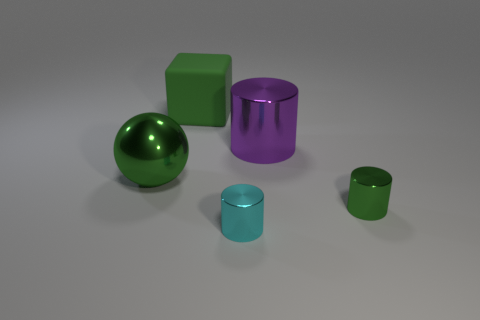Add 5 purple cylinders. How many objects exist? 10 Subtract all blocks. How many objects are left? 4 Subtract 0 brown blocks. How many objects are left? 5 Subtract all green objects. Subtract all cyan shiny things. How many objects are left? 1 Add 3 large green rubber objects. How many large green rubber objects are left? 4 Add 5 spheres. How many spheres exist? 6 